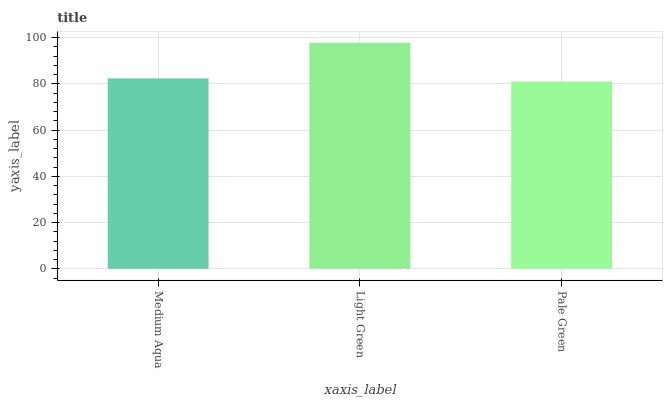Is Pale Green the minimum?
Answer yes or no. Yes. Is Light Green the maximum?
Answer yes or no. Yes. Is Light Green the minimum?
Answer yes or no. No. Is Pale Green the maximum?
Answer yes or no. No. Is Light Green greater than Pale Green?
Answer yes or no. Yes. Is Pale Green less than Light Green?
Answer yes or no. Yes. Is Pale Green greater than Light Green?
Answer yes or no. No. Is Light Green less than Pale Green?
Answer yes or no. No. Is Medium Aqua the high median?
Answer yes or no. Yes. Is Medium Aqua the low median?
Answer yes or no. Yes. Is Light Green the high median?
Answer yes or no. No. Is Pale Green the low median?
Answer yes or no. No. 